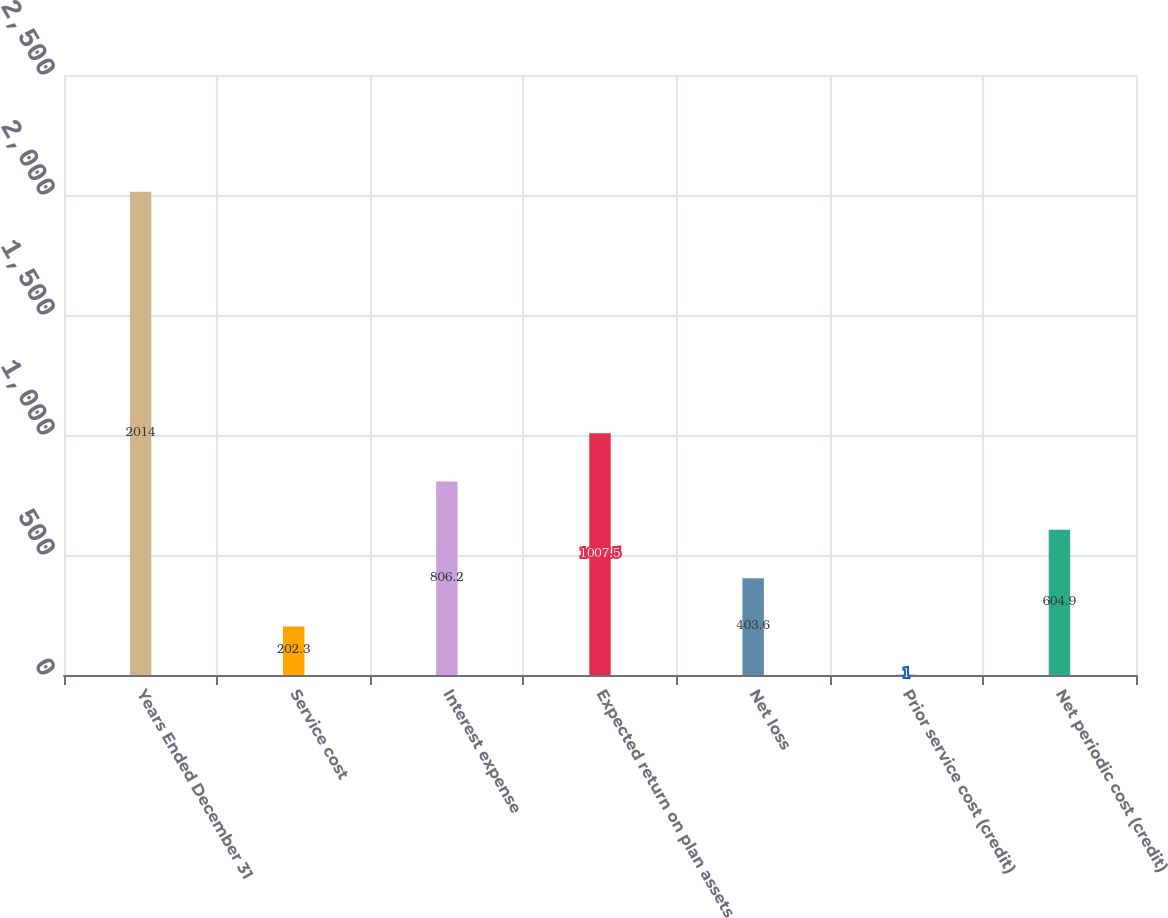<chart> <loc_0><loc_0><loc_500><loc_500><bar_chart><fcel>Years Ended December 31<fcel>Service cost<fcel>Interest expense<fcel>Expected return on plan assets<fcel>Net loss<fcel>Prior service cost (credit)<fcel>Net periodic cost (credit)<nl><fcel>2014<fcel>202.3<fcel>806.2<fcel>1007.5<fcel>403.6<fcel>1<fcel>604.9<nl></chart> 